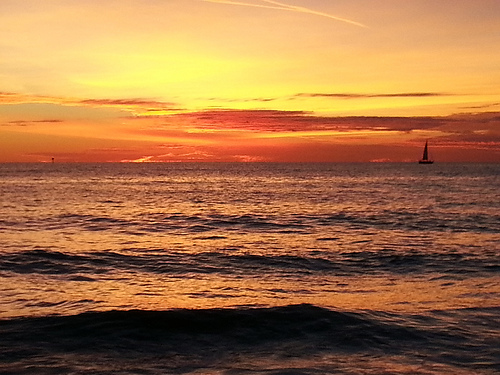<image>
Is there a boat behind the horizon? No. The boat is not behind the horizon. From this viewpoint, the boat appears to be positioned elsewhere in the scene. 